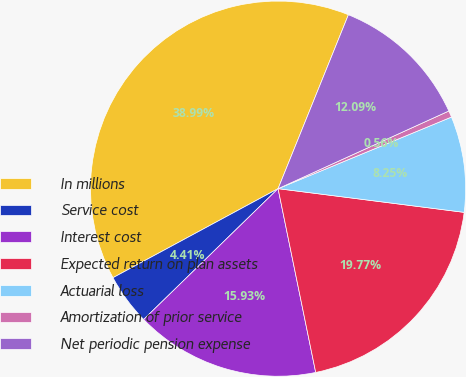<chart> <loc_0><loc_0><loc_500><loc_500><pie_chart><fcel>In millions<fcel>Service cost<fcel>Interest cost<fcel>Expected return on plan assets<fcel>Actuarial loss<fcel>Amortization of prior service<fcel>Net periodic pension expense<nl><fcel>38.99%<fcel>4.41%<fcel>15.93%<fcel>19.77%<fcel>8.25%<fcel>0.56%<fcel>12.09%<nl></chart> 